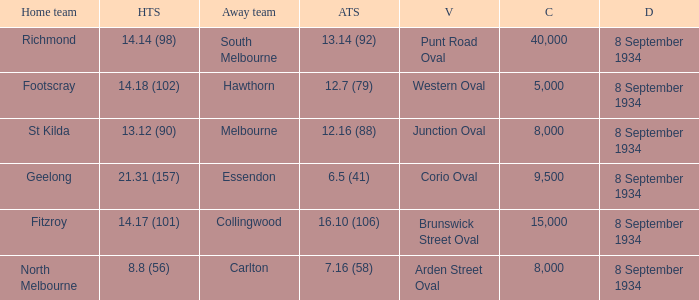When Melbourne was the Away team, what was their score? 12.16 (88). 